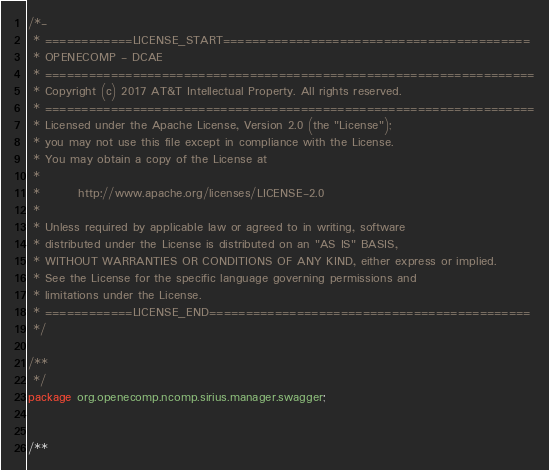Convert code to text. <code><loc_0><loc_0><loc_500><loc_500><_Java_>
/*-
 * ============LICENSE_START==========================================
 * OPENECOMP - DCAE
 * ===================================================================
 * Copyright (c) 2017 AT&T Intellectual Property. All rights reserved.
 * ===================================================================
 * Licensed under the Apache License, Version 2.0 (the "License");
 * you may not use this file except in compliance with the License.
 * You may obtain a copy of the License at
 *
 *        http://www.apache.org/licenses/LICENSE-2.0 
 *
 * Unless required by applicable law or agreed to in writing, software
 * distributed under the License is distributed on an "AS IS" BASIS,
 * WITHOUT WARRANTIES OR CONDITIONS OF ANY KIND, either express or implied.
 * See the License for the specific language governing permissions and
 * limitations under the License.
 * ============LICENSE_END============================================
 */
	
/**
 */
package org.openecomp.ncomp.sirius.manager.swagger;


/**</code> 